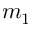Convert formula to latex. <formula><loc_0><loc_0><loc_500><loc_500>m _ { 1 }</formula> 